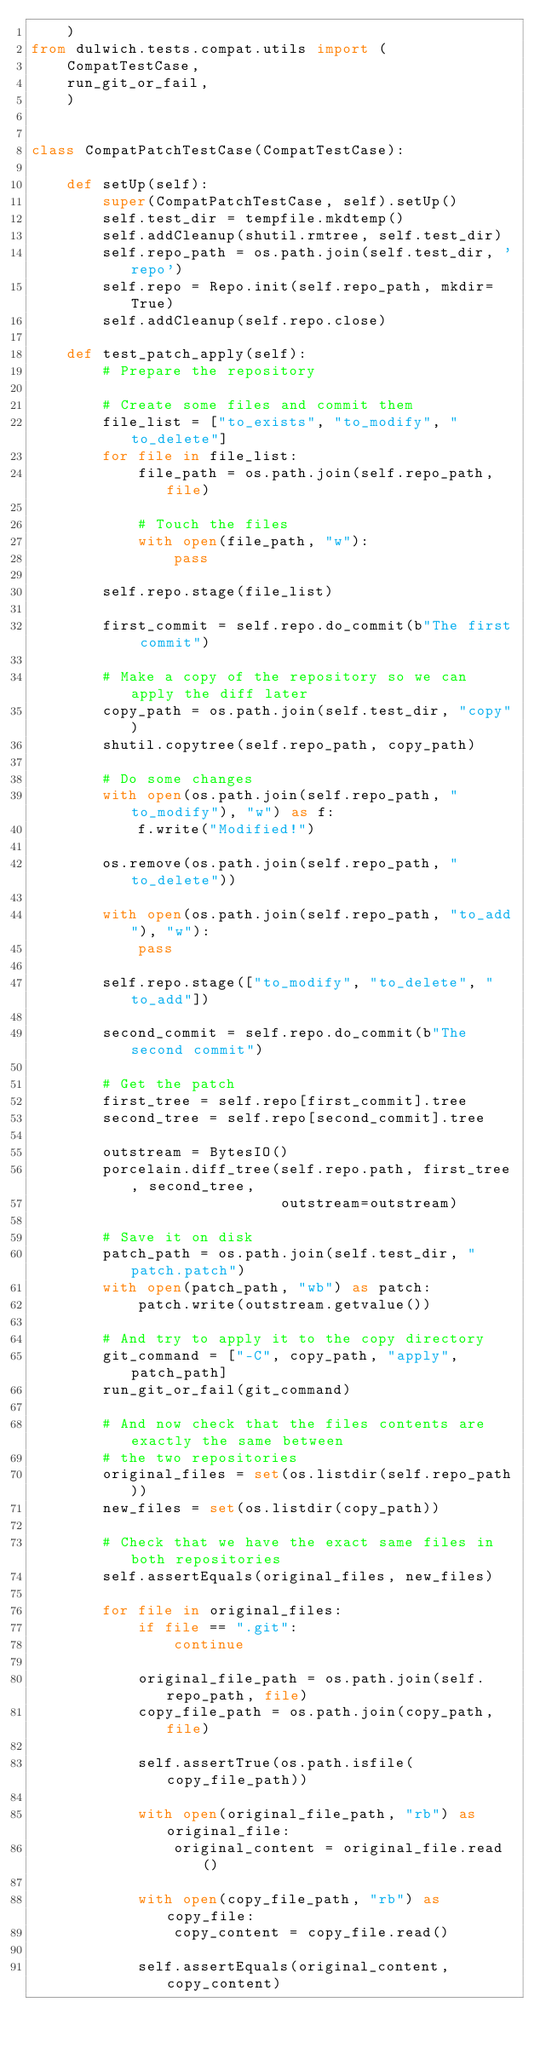Convert code to text. <code><loc_0><loc_0><loc_500><loc_500><_Python_>    )
from dulwich.tests.compat.utils import (
    CompatTestCase,
    run_git_or_fail,
    )


class CompatPatchTestCase(CompatTestCase):

    def setUp(self):
        super(CompatPatchTestCase, self).setUp()
        self.test_dir = tempfile.mkdtemp()
        self.addCleanup(shutil.rmtree, self.test_dir)
        self.repo_path = os.path.join(self.test_dir, 'repo')
        self.repo = Repo.init(self.repo_path, mkdir=True)
        self.addCleanup(self.repo.close)

    def test_patch_apply(self):
        # Prepare the repository

        # Create some files and commit them
        file_list = ["to_exists", "to_modify", "to_delete"]
        for file in file_list:
            file_path = os.path.join(self.repo_path, file)

            # Touch the files
            with open(file_path, "w"):
                pass

        self.repo.stage(file_list)

        first_commit = self.repo.do_commit(b"The first commit")

        # Make a copy of the repository so we can apply the diff later
        copy_path = os.path.join(self.test_dir, "copy")
        shutil.copytree(self.repo_path, copy_path)

        # Do some changes
        with open(os.path.join(self.repo_path, "to_modify"), "w") as f:
            f.write("Modified!")

        os.remove(os.path.join(self.repo_path, "to_delete"))

        with open(os.path.join(self.repo_path, "to_add"), "w"):
            pass

        self.repo.stage(["to_modify", "to_delete", "to_add"])

        second_commit = self.repo.do_commit(b"The second commit")

        # Get the patch
        first_tree = self.repo[first_commit].tree
        second_tree = self.repo[second_commit].tree

        outstream = BytesIO()
        porcelain.diff_tree(self.repo.path, first_tree, second_tree,
                            outstream=outstream)

        # Save it on disk
        patch_path = os.path.join(self.test_dir, "patch.patch")
        with open(patch_path, "wb") as patch:
            patch.write(outstream.getvalue())

        # And try to apply it to the copy directory
        git_command = ["-C", copy_path, "apply", patch_path]
        run_git_or_fail(git_command)

        # And now check that the files contents are exactly the same between
        # the two repositories
        original_files = set(os.listdir(self.repo_path))
        new_files = set(os.listdir(copy_path))

        # Check that we have the exact same files in both repositories
        self.assertEquals(original_files, new_files)

        for file in original_files:
            if file == ".git":
                continue

            original_file_path = os.path.join(self.repo_path, file)
            copy_file_path = os.path.join(copy_path, file)

            self.assertTrue(os.path.isfile(copy_file_path))

            with open(original_file_path, "rb") as original_file:
                original_content = original_file.read()

            with open(copy_file_path, "rb") as copy_file:
                copy_content = copy_file.read()

            self.assertEquals(original_content, copy_content)
</code> 